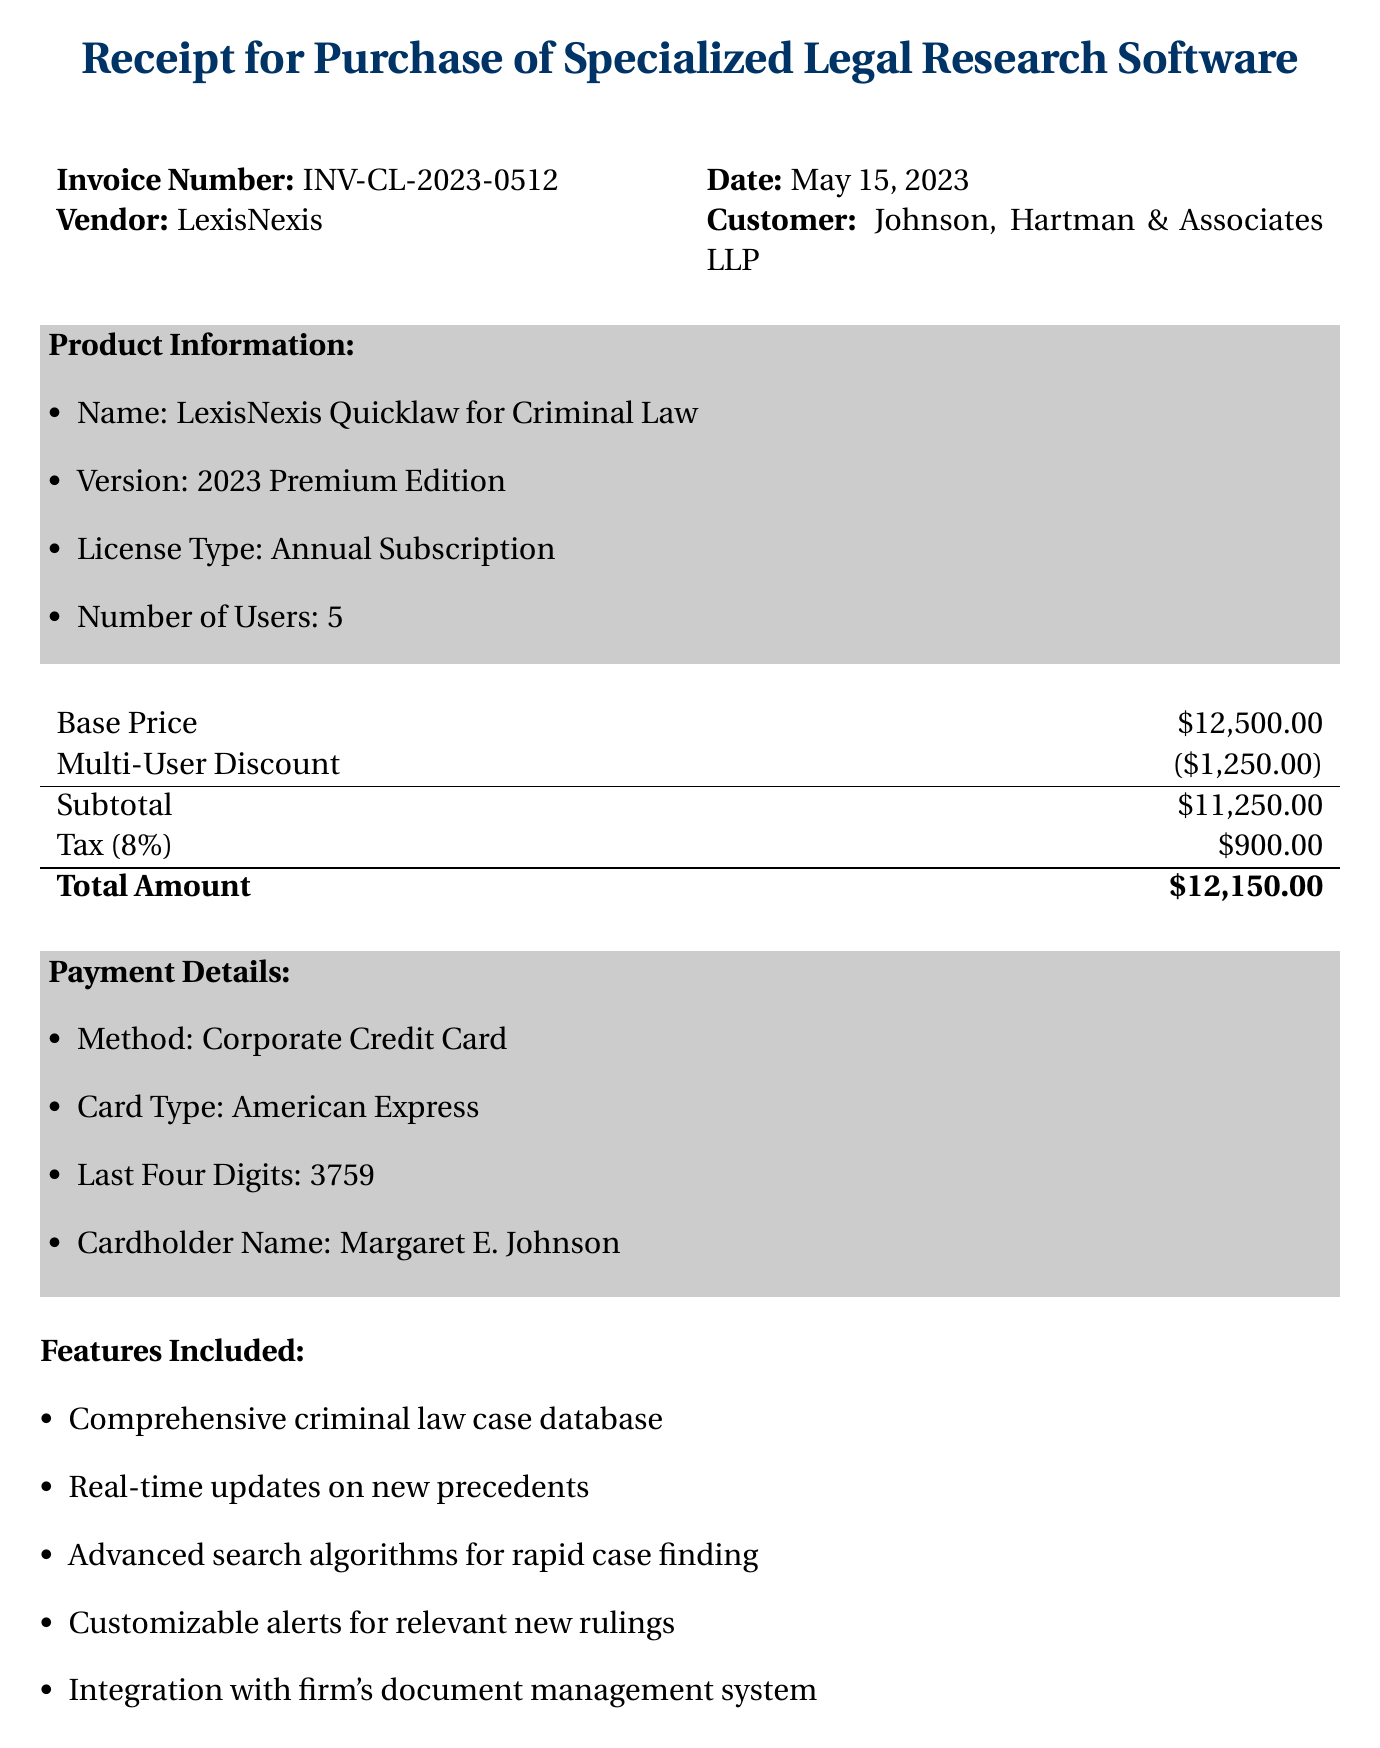What is the invoice number? The invoice number can be found under the transaction details section of the document.
Answer: INV-CL-2023-0512 Who is the vendor for the software? The vendor is identified in the transaction details section.
Answer: LexisNexis What is the base price of the software? The base price is mentioned in the pricing section.
Answer: $12,500.00 What is the total amount due? The total amount is calculated from the subtotal and tax in the pricing section.
Answer: $12,150.00 How many users does the license accommodate? The number of users is specified in the product information section.
Answer: 5 What features are included with the software? The features are listed at the end of the document under features included.
Answer: Comprehensive criminal law case database, Real-time updates on new precedents, Advanced search algorithms for rapid case finding, Customizable alerts for relevant new rulings, Integration with firm's document management system Why was the purchase authorized? The additional notes provide a reason for the authorization of the purchase.
Answer: Firm meeting on 2023-05-10 When is the mandatory training session scheduled? The training session's date is noted in the additional notes section.
Answer: 2023-05-22 